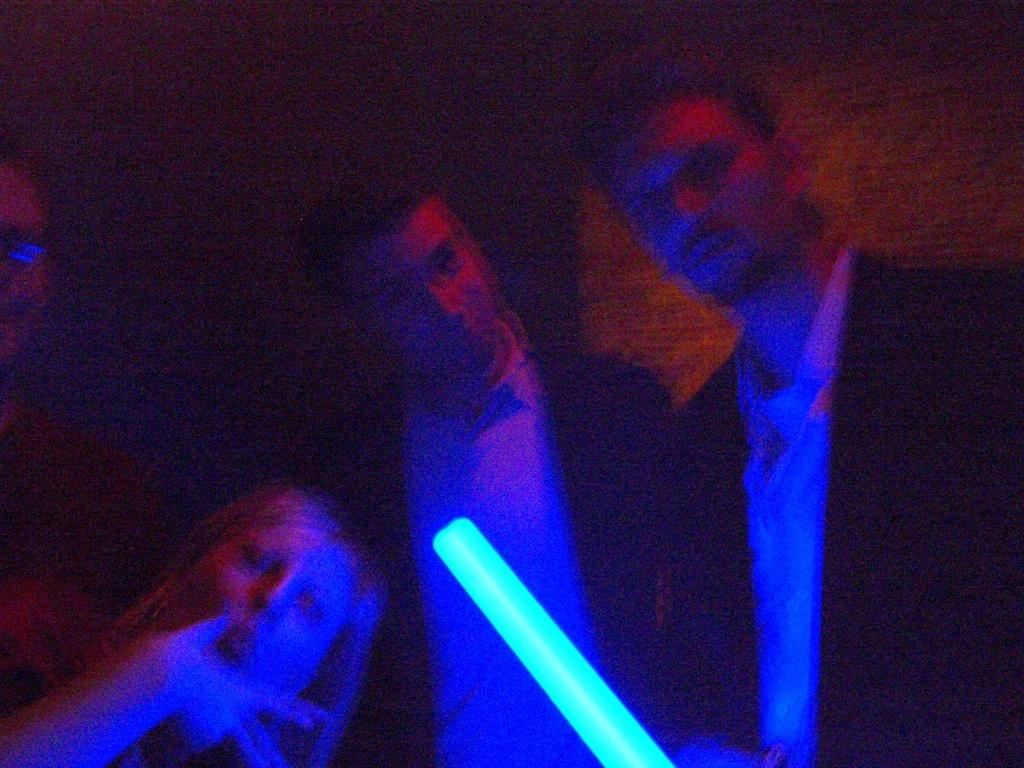What is the main focus of the image? The main focus of the image is the persons in the center of the image. Can you describe the background of the image? The background of the image is blurry. What type of whip can be seen in the hands of the men in the image? There are no men or whips present in the image. How does the snow affect the visibility of the persons in the image? There is no snow present in the image, so it does not affect the visibility of the persons. 